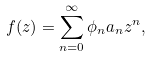<formula> <loc_0><loc_0><loc_500><loc_500>f ( z ) = \sum _ { n = 0 } ^ { \infty } \phi _ { n } a _ { n } z ^ { n } ,</formula> 